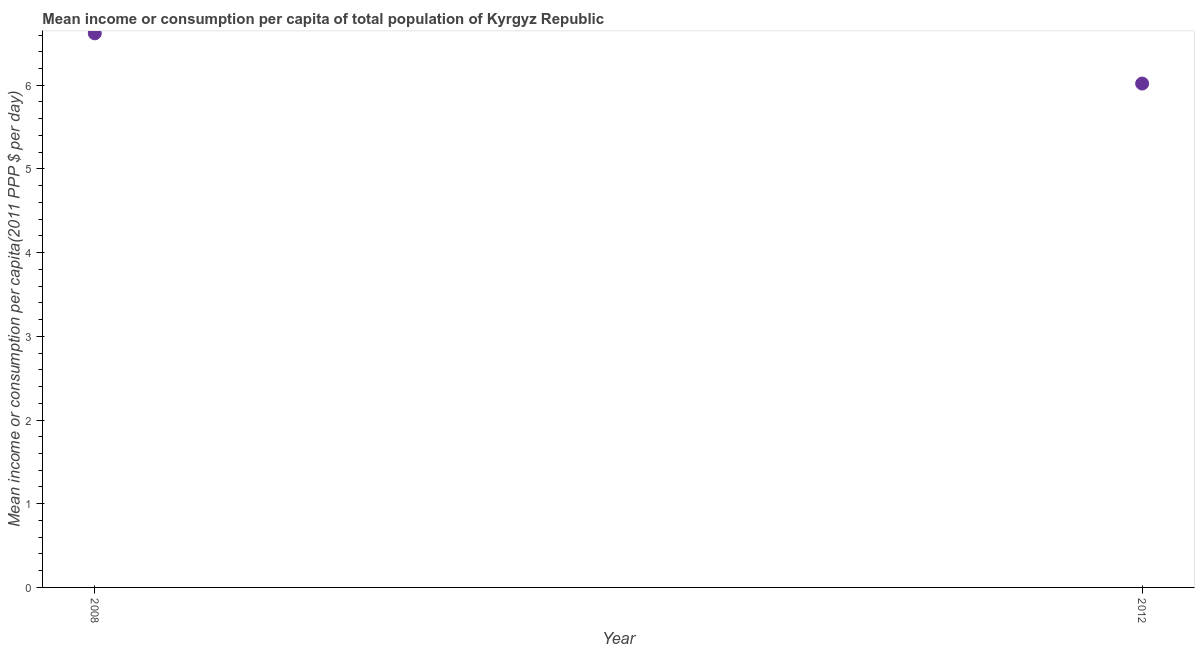What is the mean income or consumption in 2012?
Ensure brevity in your answer.  6.02. Across all years, what is the maximum mean income or consumption?
Make the answer very short. 6.62. Across all years, what is the minimum mean income or consumption?
Your response must be concise. 6.02. What is the sum of the mean income or consumption?
Provide a short and direct response. 12.64. What is the difference between the mean income or consumption in 2008 and 2012?
Ensure brevity in your answer.  0.6. What is the average mean income or consumption per year?
Offer a terse response. 6.32. What is the median mean income or consumption?
Provide a short and direct response. 6.32. In how many years, is the mean income or consumption greater than 1.8 $?
Give a very brief answer. 2. What is the ratio of the mean income or consumption in 2008 to that in 2012?
Offer a terse response. 1.1. Is the mean income or consumption in 2008 less than that in 2012?
Make the answer very short. No. In how many years, is the mean income or consumption greater than the average mean income or consumption taken over all years?
Your answer should be very brief. 1. Does the graph contain grids?
Give a very brief answer. No. What is the title of the graph?
Ensure brevity in your answer.  Mean income or consumption per capita of total population of Kyrgyz Republic. What is the label or title of the Y-axis?
Offer a very short reply. Mean income or consumption per capita(2011 PPP $ per day). What is the Mean income or consumption per capita(2011 PPP $ per day) in 2008?
Offer a terse response. 6.62. What is the Mean income or consumption per capita(2011 PPP $ per day) in 2012?
Offer a terse response. 6.02. What is the difference between the Mean income or consumption per capita(2011 PPP $ per day) in 2008 and 2012?
Offer a very short reply. 0.6. What is the ratio of the Mean income or consumption per capita(2011 PPP $ per day) in 2008 to that in 2012?
Make the answer very short. 1.1. 